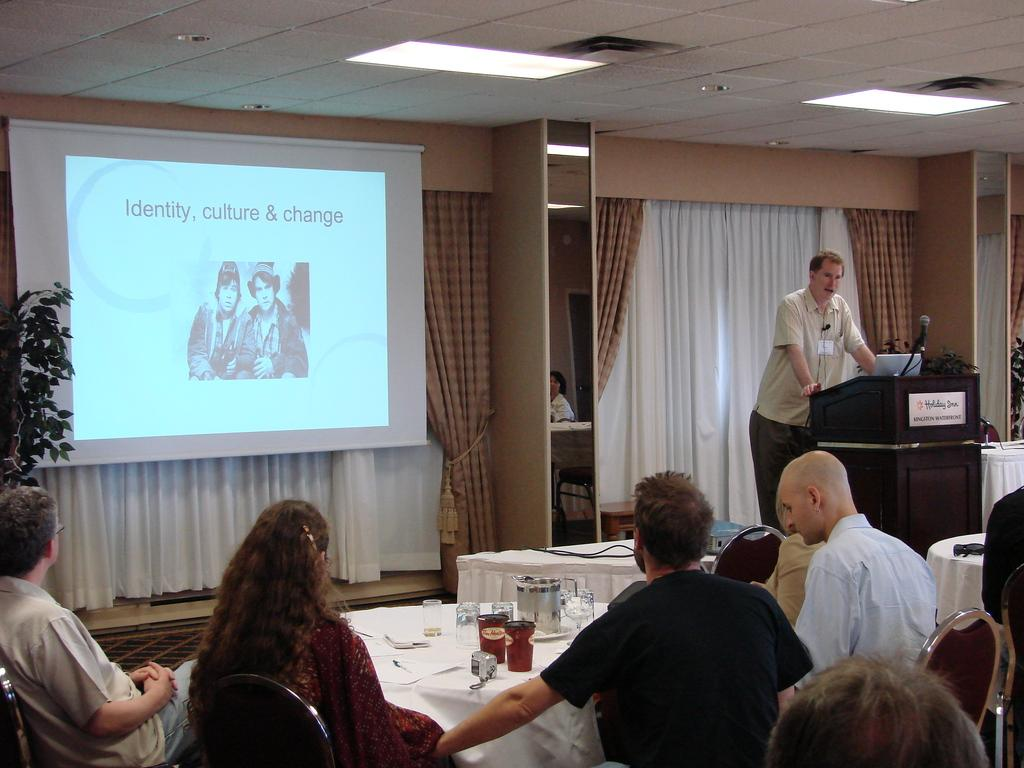<image>
Render a clear and concise summary of the photo. A man standing at a podium at a Holiday Inn conference room giving a presentation about identity, culture and change. 